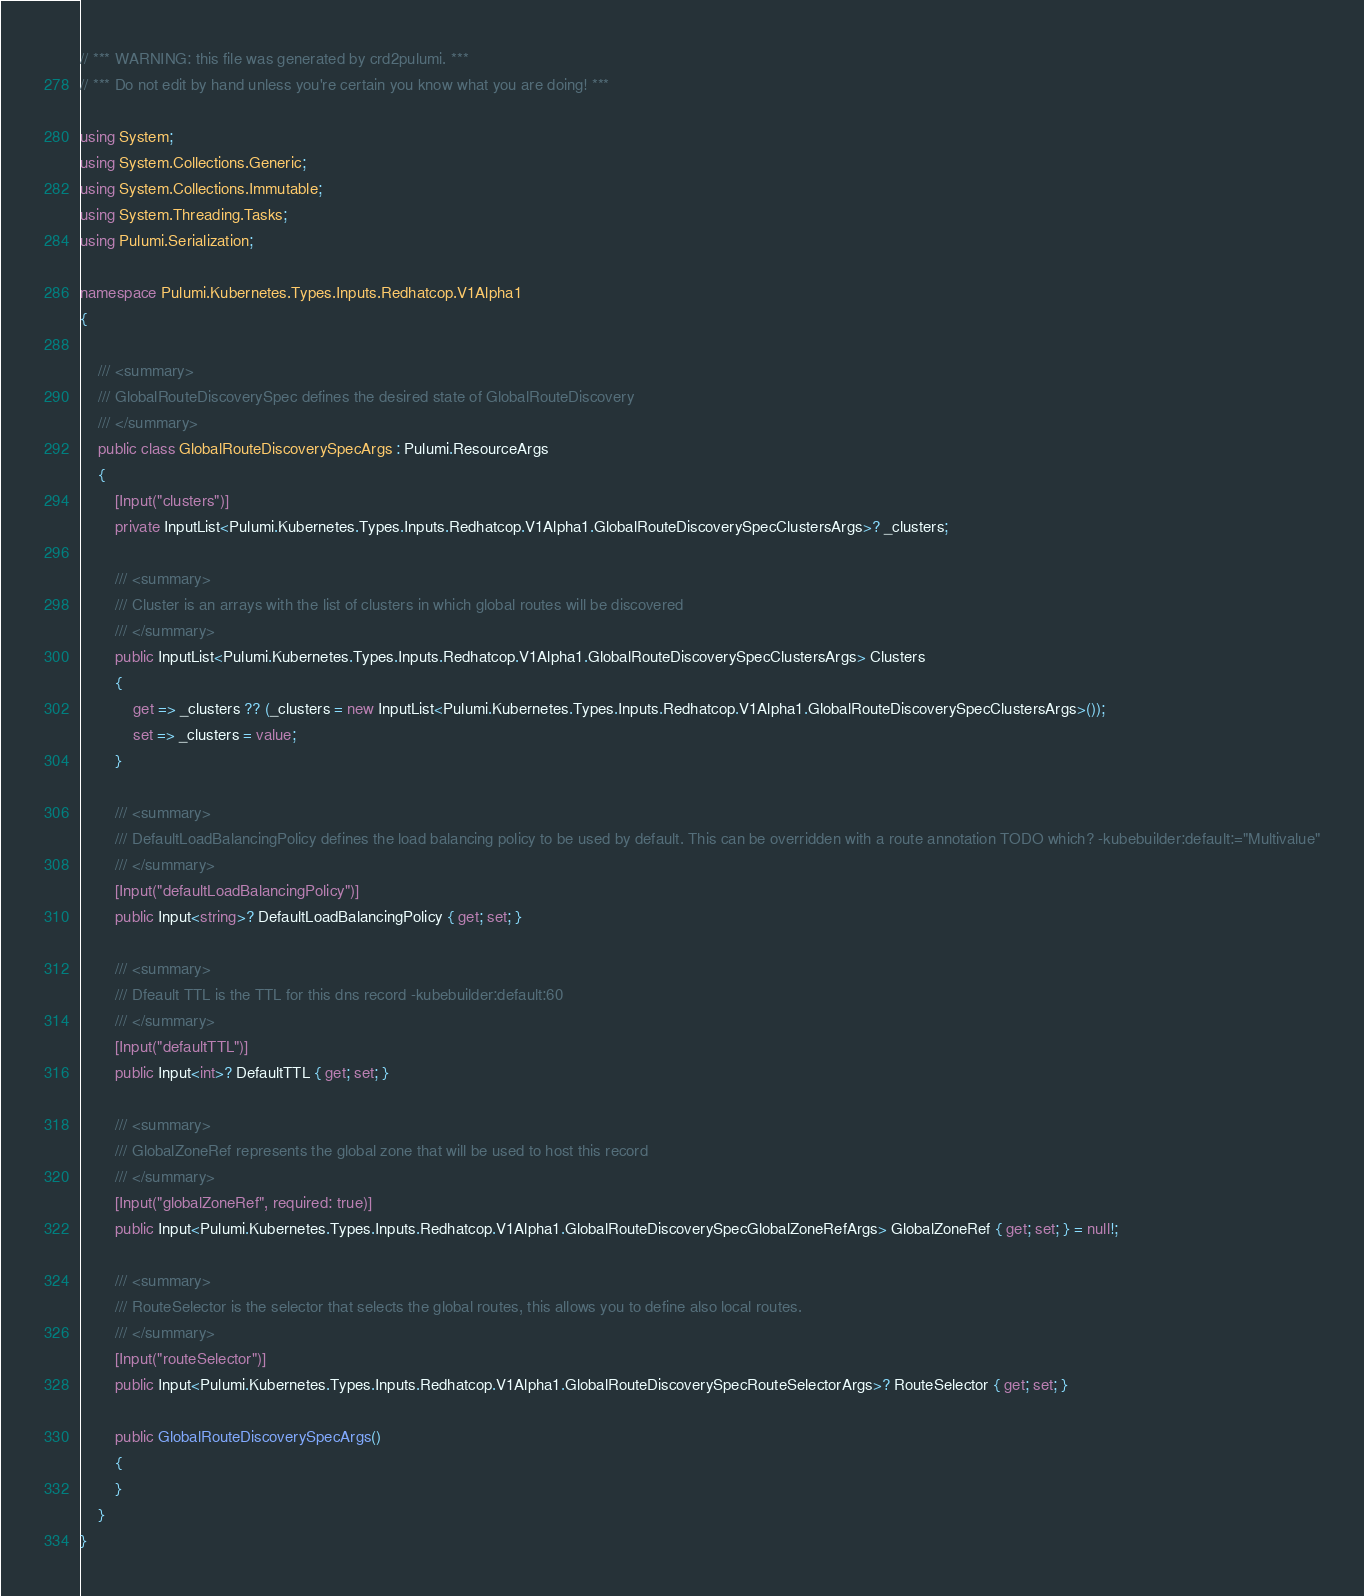<code> <loc_0><loc_0><loc_500><loc_500><_C#_>// *** WARNING: this file was generated by crd2pulumi. ***
// *** Do not edit by hand unless you're certain you know what you are doing! ***

using System;
using System.Collections.Generic;
using System.Collections.Immutable;
using System.Threading.Tasks;
using Pulumi.Serialization;

namespace Pulumi.Kubernetes.Types.Inputs.Redhatcop.V1Alpha1
{

    /// <summary>
    /// GlobalRouteDiscoverySpec defines the desired state of GlobalRouteDiscovery
    /// </summary>
    public class GlobalRouteDiscoverySpecArgs : Pulumi.ResourceArgs
    {
        [Input("clusters")]
        private InputList<Pulumi.Kubernetes.Types.Inputs.Redhatcop.V1Alpha1.GlobalRouteDiscoverySpecClustersArgs>? _clusters;

        /// <summary>
        /// Cluster is an arrays with the list of clusters in which global routes will be discovered
        /// </summary>
        public InputList<Pulumi.Kubernetes.Types.Inputs.Redhatcop.V1Alpha1.GlobalRouteDiscoverySpecClustersArgs> Clusters
        {
            get => _clusters ?? (_clusters = new InputList<Pulumi.Kubernetes.Types.Inputs.Redhatcop.V1Alpha1.GlobalRouteDiscoverySpecClustersArgs>());
            set => _clusters = value;
        }

        /// <summary>
        /// DefaultLoadBalancingPolicy defines the load balancing policy to be used by default. This can be overridden with a route annotation TODO which? -kubebuilder:default:="Multivalue"
        /// </summary>
        [Input("defaultLoadBalancingPolicy")]
        public Input<string>? DefaultLoadBalancingPolicy { get; set; }

        /// <summary>
        /// Dfeault TTL is the TTL for this dns record -kubebuilder:default:60
        /// </summary>
        [Input("defaultTTL")]
        public Input<int>? DefaultTTL { get; set; }

        /// <summary>
        /// GlobalZoneRef represents the global zone that will be used to host this record
        /// </summary>
        [Input("globalZoneRef", required: true)]
        public Input<Pulumi.Kubernetes.Types.Inputs.Redhatcop.V1Alpha1.GlobalRouteDiscoverySpecGlobalZoneRefArgs> GlobalZoneRef { get; set; } = null!;

        /// <summary>
        /// RouteSelector is the selector that selects the global routes, this allows you to define also local routes.
        /// </summary>
        [Input("routeSelector")]
        public Input<Pulumi.Kubernetes.Types.Inputs.Redhatcop.V1Alpha1.GlobalRouteDiscoverySpecRouteSelectorArgs>? RouteSelector { get; set; }

        public GlobalRouteDiscoverySpecArgs()
        {
        }
    }
}
</code> 